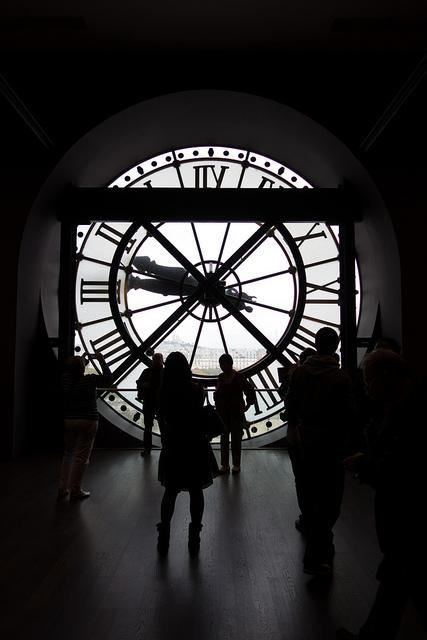What time is depicted in the photo?

Choices:
A) 815
B) 945
C) 215
D) 145 215 